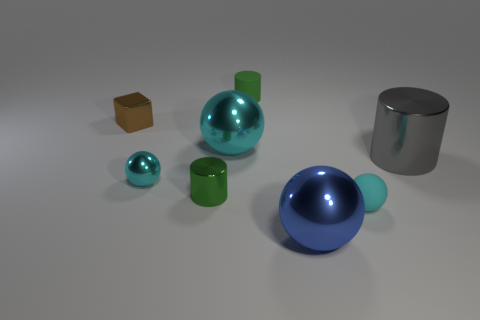Subtract all red cubes. How many cyan balls are left? 3 Add 1 large gray objects. How many objects exist? 9 Subtract all blocks. How many objects are left? 7 Add 1 small cyan objects. How many small cyan objects exist? 3 Subtract 0 red cubes. How many objects are left? 8 Subtract all large gray shiny objects. Subtract all rubber spheres. How many objects are left? 6 Add 2 gray metal objects. How many gray metal objects are left? 3 